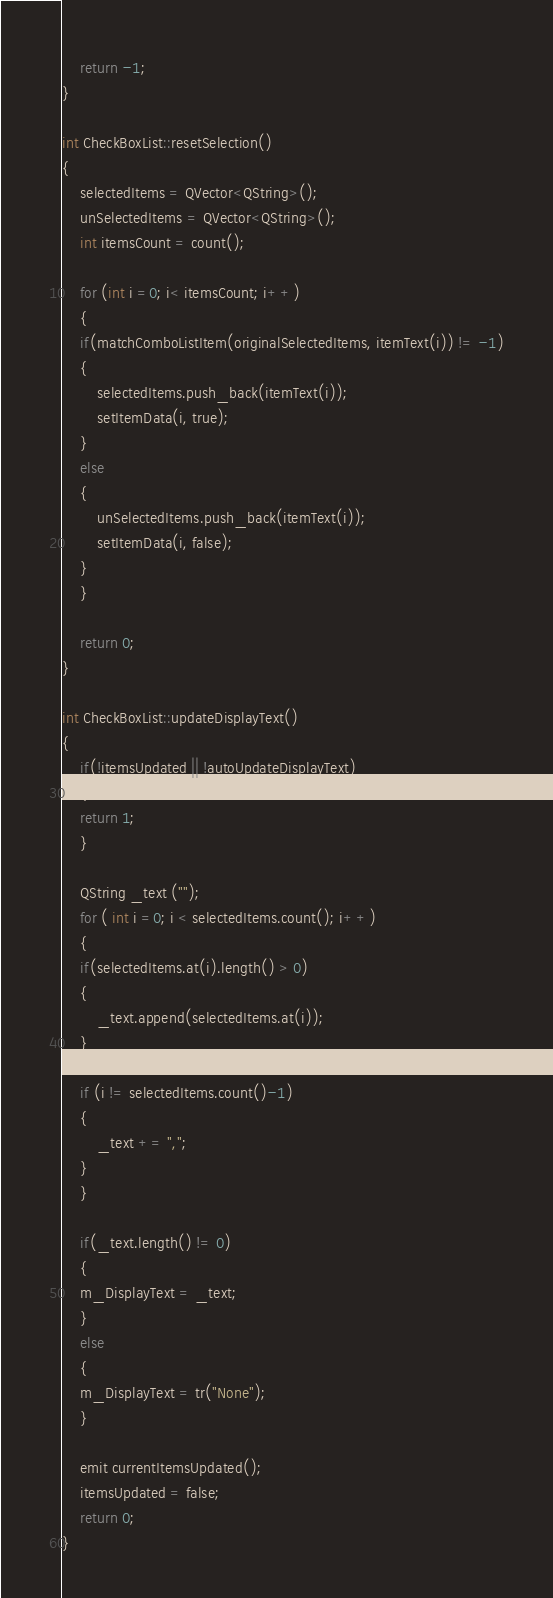<code> <loc_0><loc_0><loc_500><loc_500><_C++_>    return -1;
}

int CheckBoxList::resetSelection()
{
    selectedItems = QVector<QString>();
    unSelectedItems = QVector<QString>();
    int itemsCount = count();

    for (int i =0; i< itemsCount; i++)
    {
	if(matchComboListItem(originalSelectedItems, itemText(i)) != -1)
	{
	    selectedItems.push_back(itemText(i));
	    setItemData(i, true);
	}
	else
	{
	    unSelectedItems.push_back(itemText(i));
	    setItemData(i, false);
	}
    }

    return 0;
}

int CheckBoxList::updateDisplayText()
{
    if(!itemsUpdated || !autoUpdateDisplayText)
    {
	return 1;
    }

    QString _text ("");
    for ( int i =0; i < selectedItems.count(); i++)
    {
	if(selectedItems.at(i).length() > 0)
	{
	    _text.append(selectedItems.at(i));
	}

	if (i != selectedItems.count()-1)
	{
	    _text += ",";
	}
    }

    if(_text.length() != 0)
    {
	m_DisplayText = _text;
    }
    else
    {
	m_DisplayText = tr("None");
    }

    emit currentItemsUpdated();
    itemsUpdated = false;
    return 0;
}
</code> 